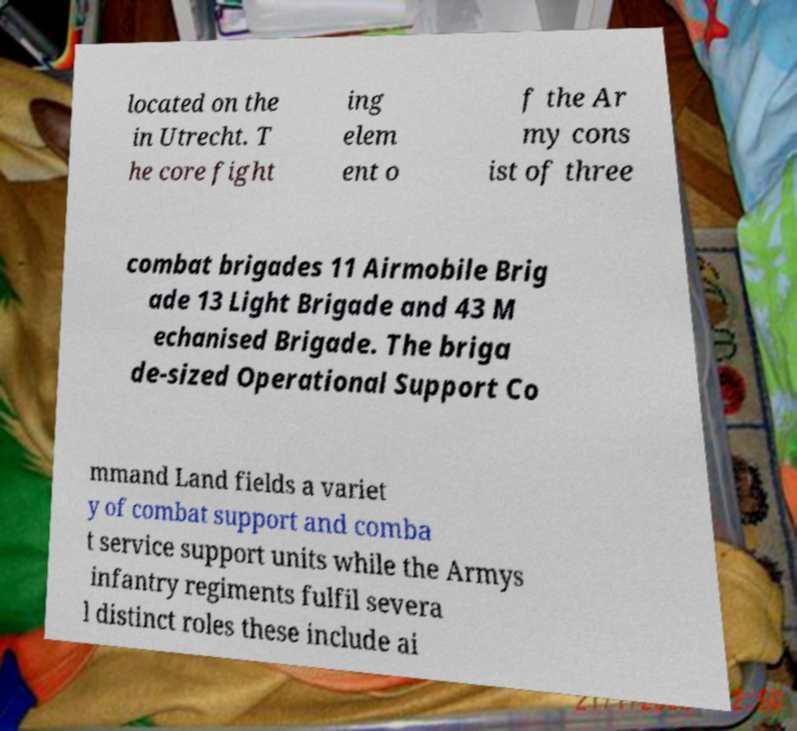Please read and relay the text visible in this image. What does it say? located on the in Utrecht. T he core fight ing elem ent o f the Ar my cons ist of three combat brigades 11 Airmobile Brig ade 13 Light Brigade and 43 M echanised Brigade. The briga de-sized Operational Support Co mmand Land fields a variet y of combat support and comba t service support units while the Armys infantry regiments fulfil severa l distinct roles these include ai 